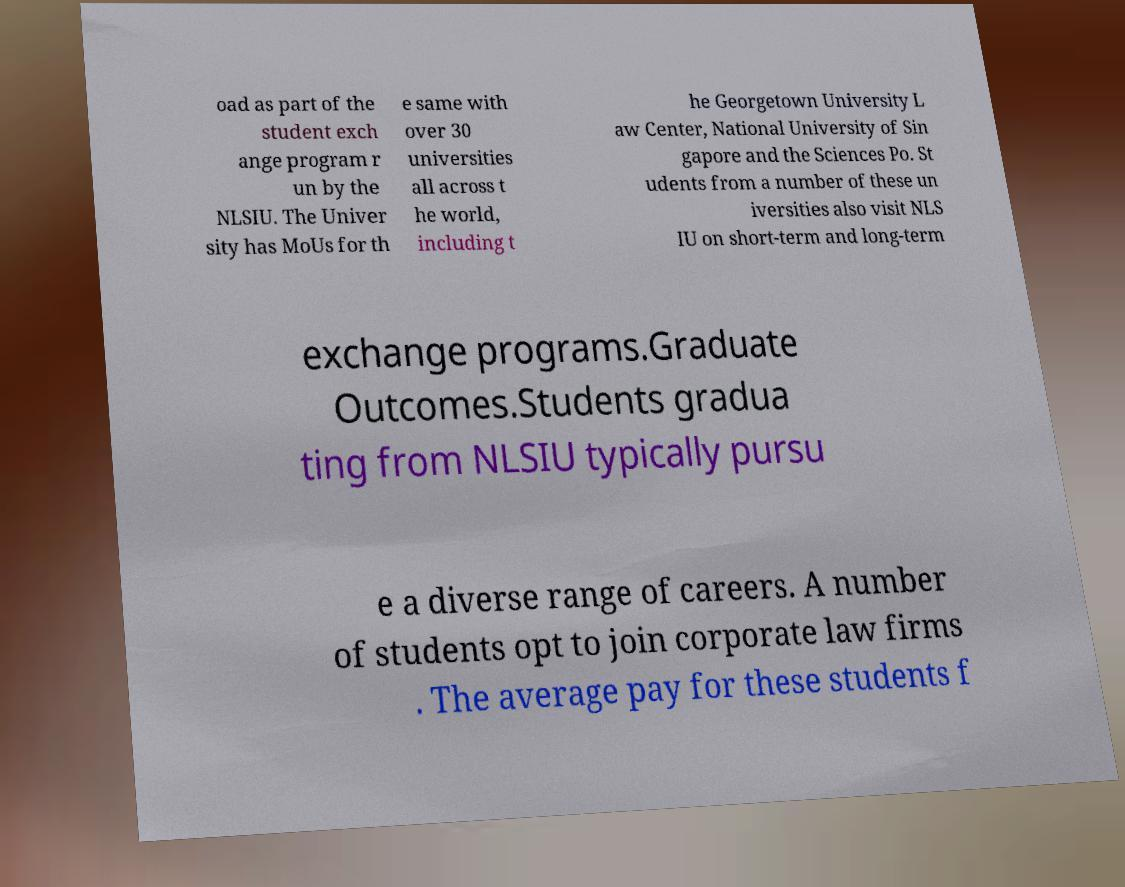There's text embedded in this image that I need extracted. Can you transcribe it verbatim? oad as part of the student exch ange program r un by the NLSIU. The Univer sity has MoUs for th e same with over 30 universities all across t he world, including t he Georgetown University L aw Center, National University of Sin gapore and the Sciences Po. St udents from a number of these un iversities also visit NLS IU on short-term and long-term exchange programs.Graduate Outcomes.Students gradua ting from NLSIU typically pursu e a diverse range of careers. A number of students opt to join corporate law firms . The average pay for these students f 